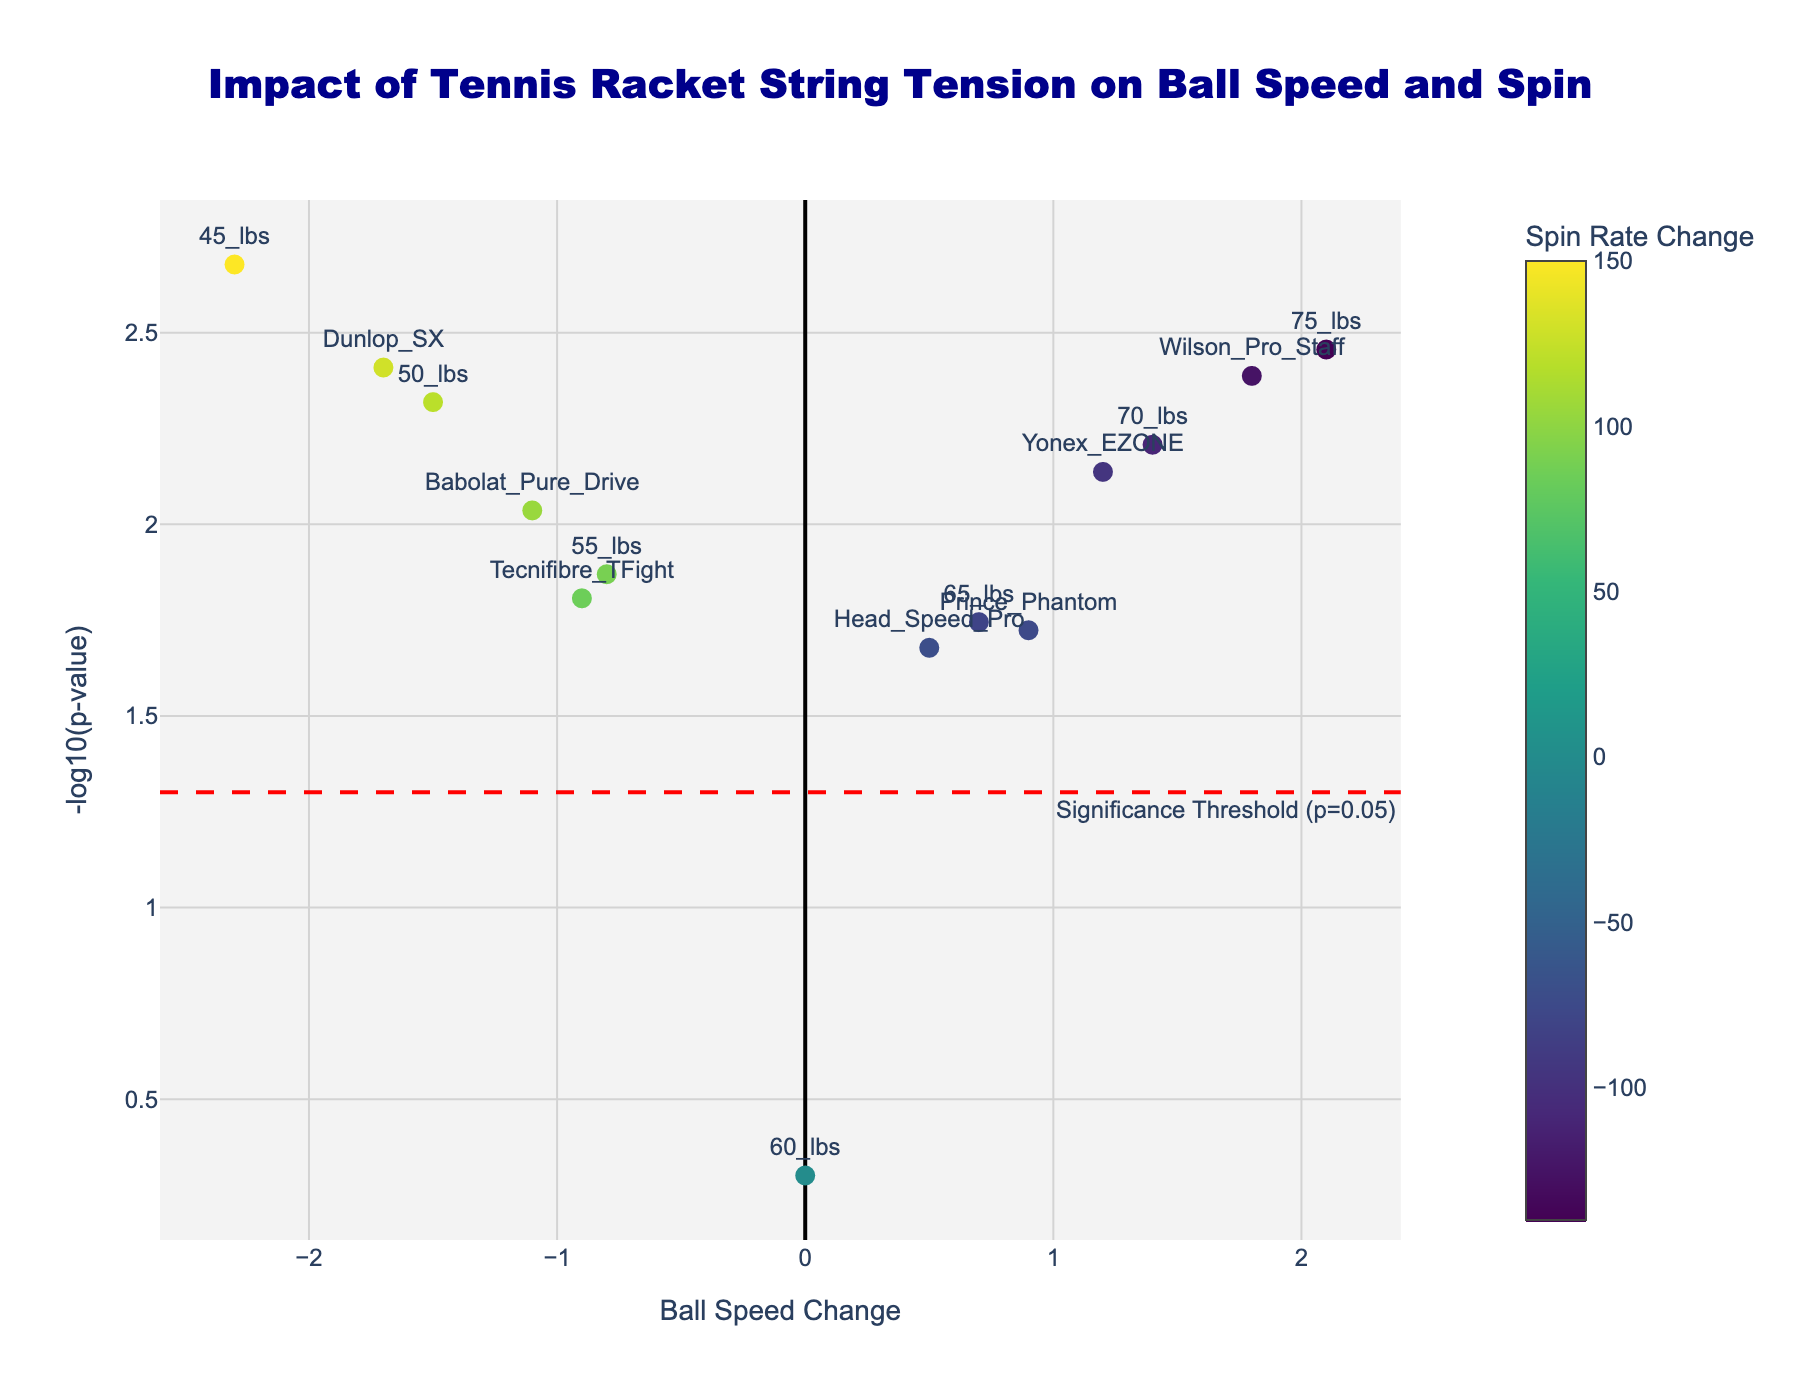What is the title of the figure? The title of the figure is prominently displayed at the top of the plot, denoted in a large font size. It reads "Impact of Tennis Racket String Tension on Ball Speed and Spin".
Answer: Impact of Tennis Racket String Tension on Ball Speed and Spin How many data points are labeled as significant? Data points labeled as significant can be identified by looking at the y-axis and noting which points fall above the red threshold line that denotes `-log10(p-value) = 1.3010`. There are 12 such points.
Answer: 12 Which string tension resulted in the largest positive change in ball speed? Observing the x-axis values for ball speed changes, the point furthest to the right represents the largest positive change. This corresponds to the 75 lbs tension.
Answer: 75 lbs Which data point is associated with zero ball speed change? By finding the point located at the x-axis value of zero, you can see that it is labeled "60 lbs".
Answer: 60 lbs What is the p-value for the Wilson Pro Staff racket? By hovering over or identifying the scatter point labeled as "Wilson Pro Staff", you can see its p-value is provided as 0.0041.
Answer: 0.0041 What is the significance threshold used in the plot? The red dashed line annotated with "Significance Threshold (p=0.05)" indicates the significance threshold level used, which translates to `-log10(p-value) = 1.3010`.
Answer: p=0.05 Compare the string tensions 45 lbs and 75 lbs in terms of their ball speed change and spin rate change. From the figure, the point labeled "45 lbs" has a ball speed change of -2.3 and a spin rate change of 150, while the point labeled "75 lbs" has a ball speed change of 2.1 and a spin rate change of -140. Therefore, 45 lbs results in a decrease in ball speed and an increase in spin rate, whereas 75 lbs results in an increase in ball speed and a decrease in spin rate.
Answer: 45 lbs: -2.3 (speed), 150 (spin); 75 lbs: 2.1 (speed), -140 (spin) Which data point has the smallest p-value, indicating the most significant result? By comparing the y-axis values, the point with the highest `-log10(p-value)` signifies the smallest p-value. This appears to be the data point "45 lbs".
Answer: 45 lbs Which string tension has the least impact on ball speed, based on the x-axis? The string tension with the ball speed change closest to zero on the x-axis is "60 lbs", which has a ball speed change of 0.
Answer: 60 lbs 